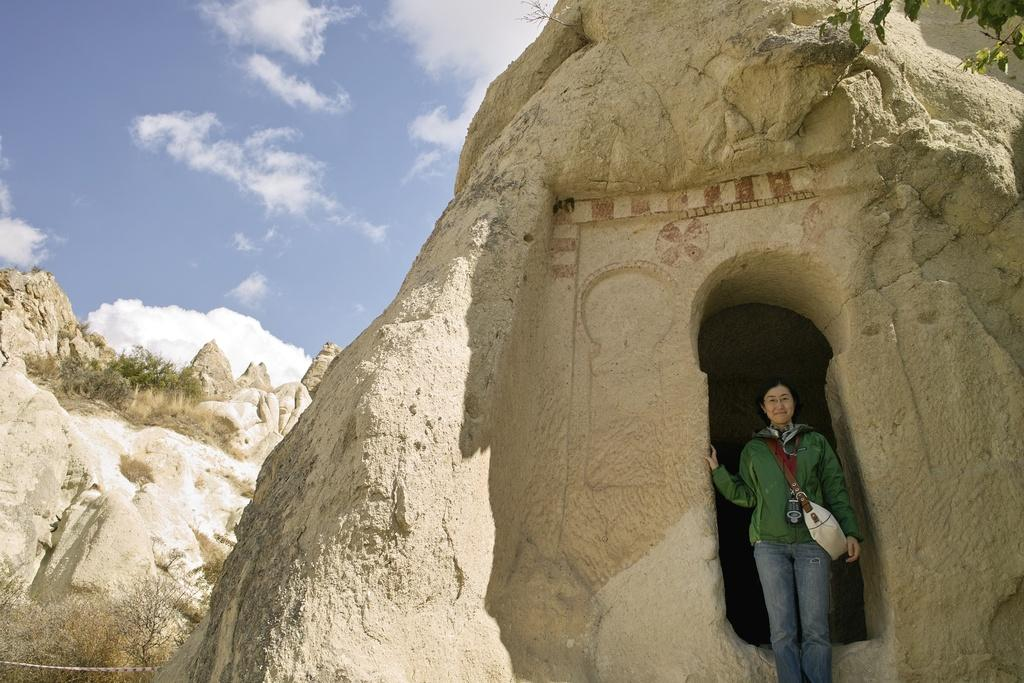Who is present in the image on the right side? There is a woman standing on the right side of the image. What is the location or setting of the image? The setting appears to be a cave. What can be seen in the background of the image? There are trees and stones in the background of the image. What is visible at the top of the image? The sky is visible at the top of the image. What type of thread is being used to sew the ants together in the image? There are no ants or thread present in the image; it features a woman standing in a cave with trees, stones, and a visible sky in the background. 